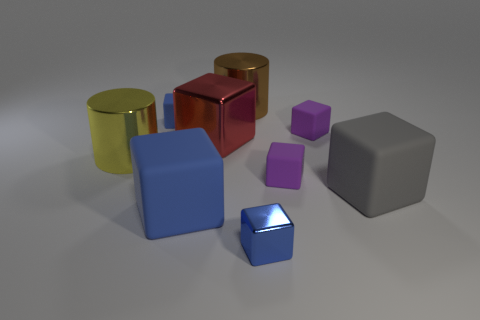What is the shape of the gray thing that is the same size as the red object?
Your response must be concise. Cube. What number of cyan objects are either tiny objects or large cylinders?
Offer a very short reply. 0. How many things are the same size as the brown shiny cylinder?
Give a very brief answer. 4. There is a large rubber thing that is the same color as the small metal block; what shape is it?
Provide a short and direct response. Cube. How many things are large cyan rubber cylinders or shiny objects left of the big brown thing?
Your response must be concise. 2. Do the brown cylinder that is on the right side of the red metallic object and the purple object that is in front of the yellow cylinder have the same size?
Offer a very short reply. No. How many big red things are the same shape as the big yellow metallic object?
Keep it short and to the point. 0. The large red object that is made of the same material as the yellow object is what shape?
Offer a very short reply. Cube. What material is the purple thing that is on the left side of the tiny purple cube that is behind the cylinder in front of the big red metallic object?
Keep it short and to the point. Rubber. Does the brown cylinder have the same size as the metallic block that is to the left of the small blue metallic object?
Give a very brief answer. Yes. 